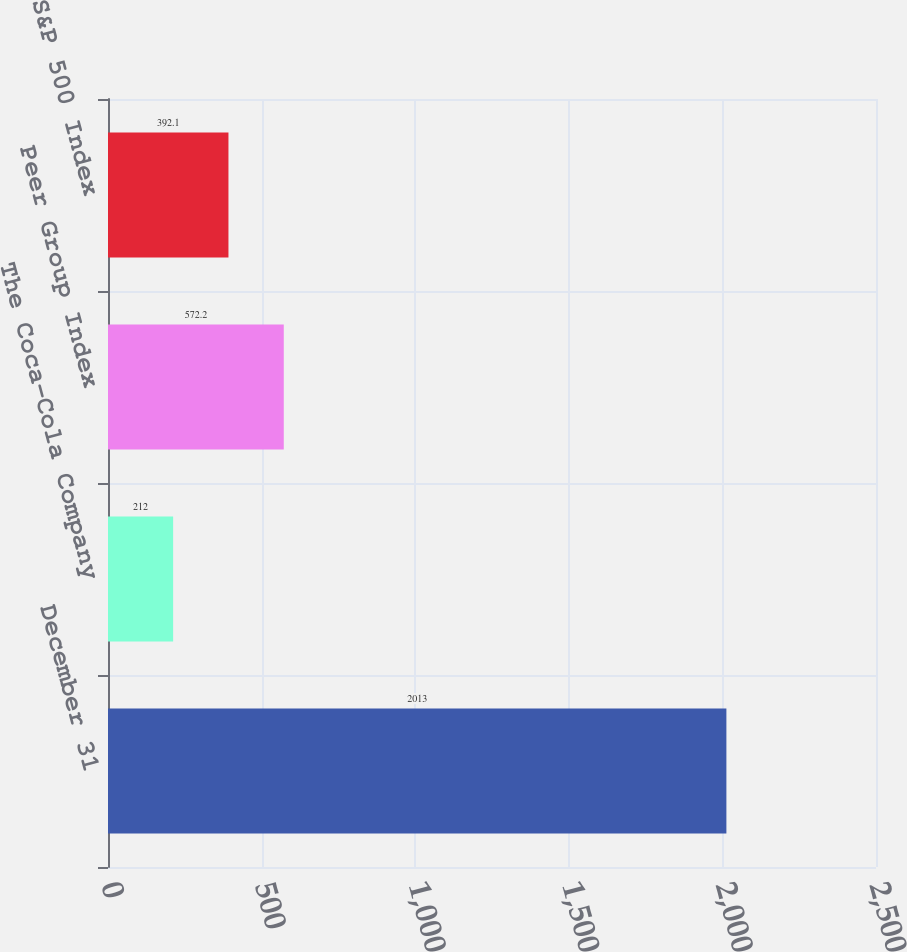<chart> <loc_0><loc_0><loc_500><loc_500><bar_chart><fcel>December 31<fcel>The Coca-Cola Company<fcel>Peer Group Index<fcel>S&P 500 Index<nl><fcel>2013<fcel>212<fcel>572.2<fcel>392.1<nl></chart> 